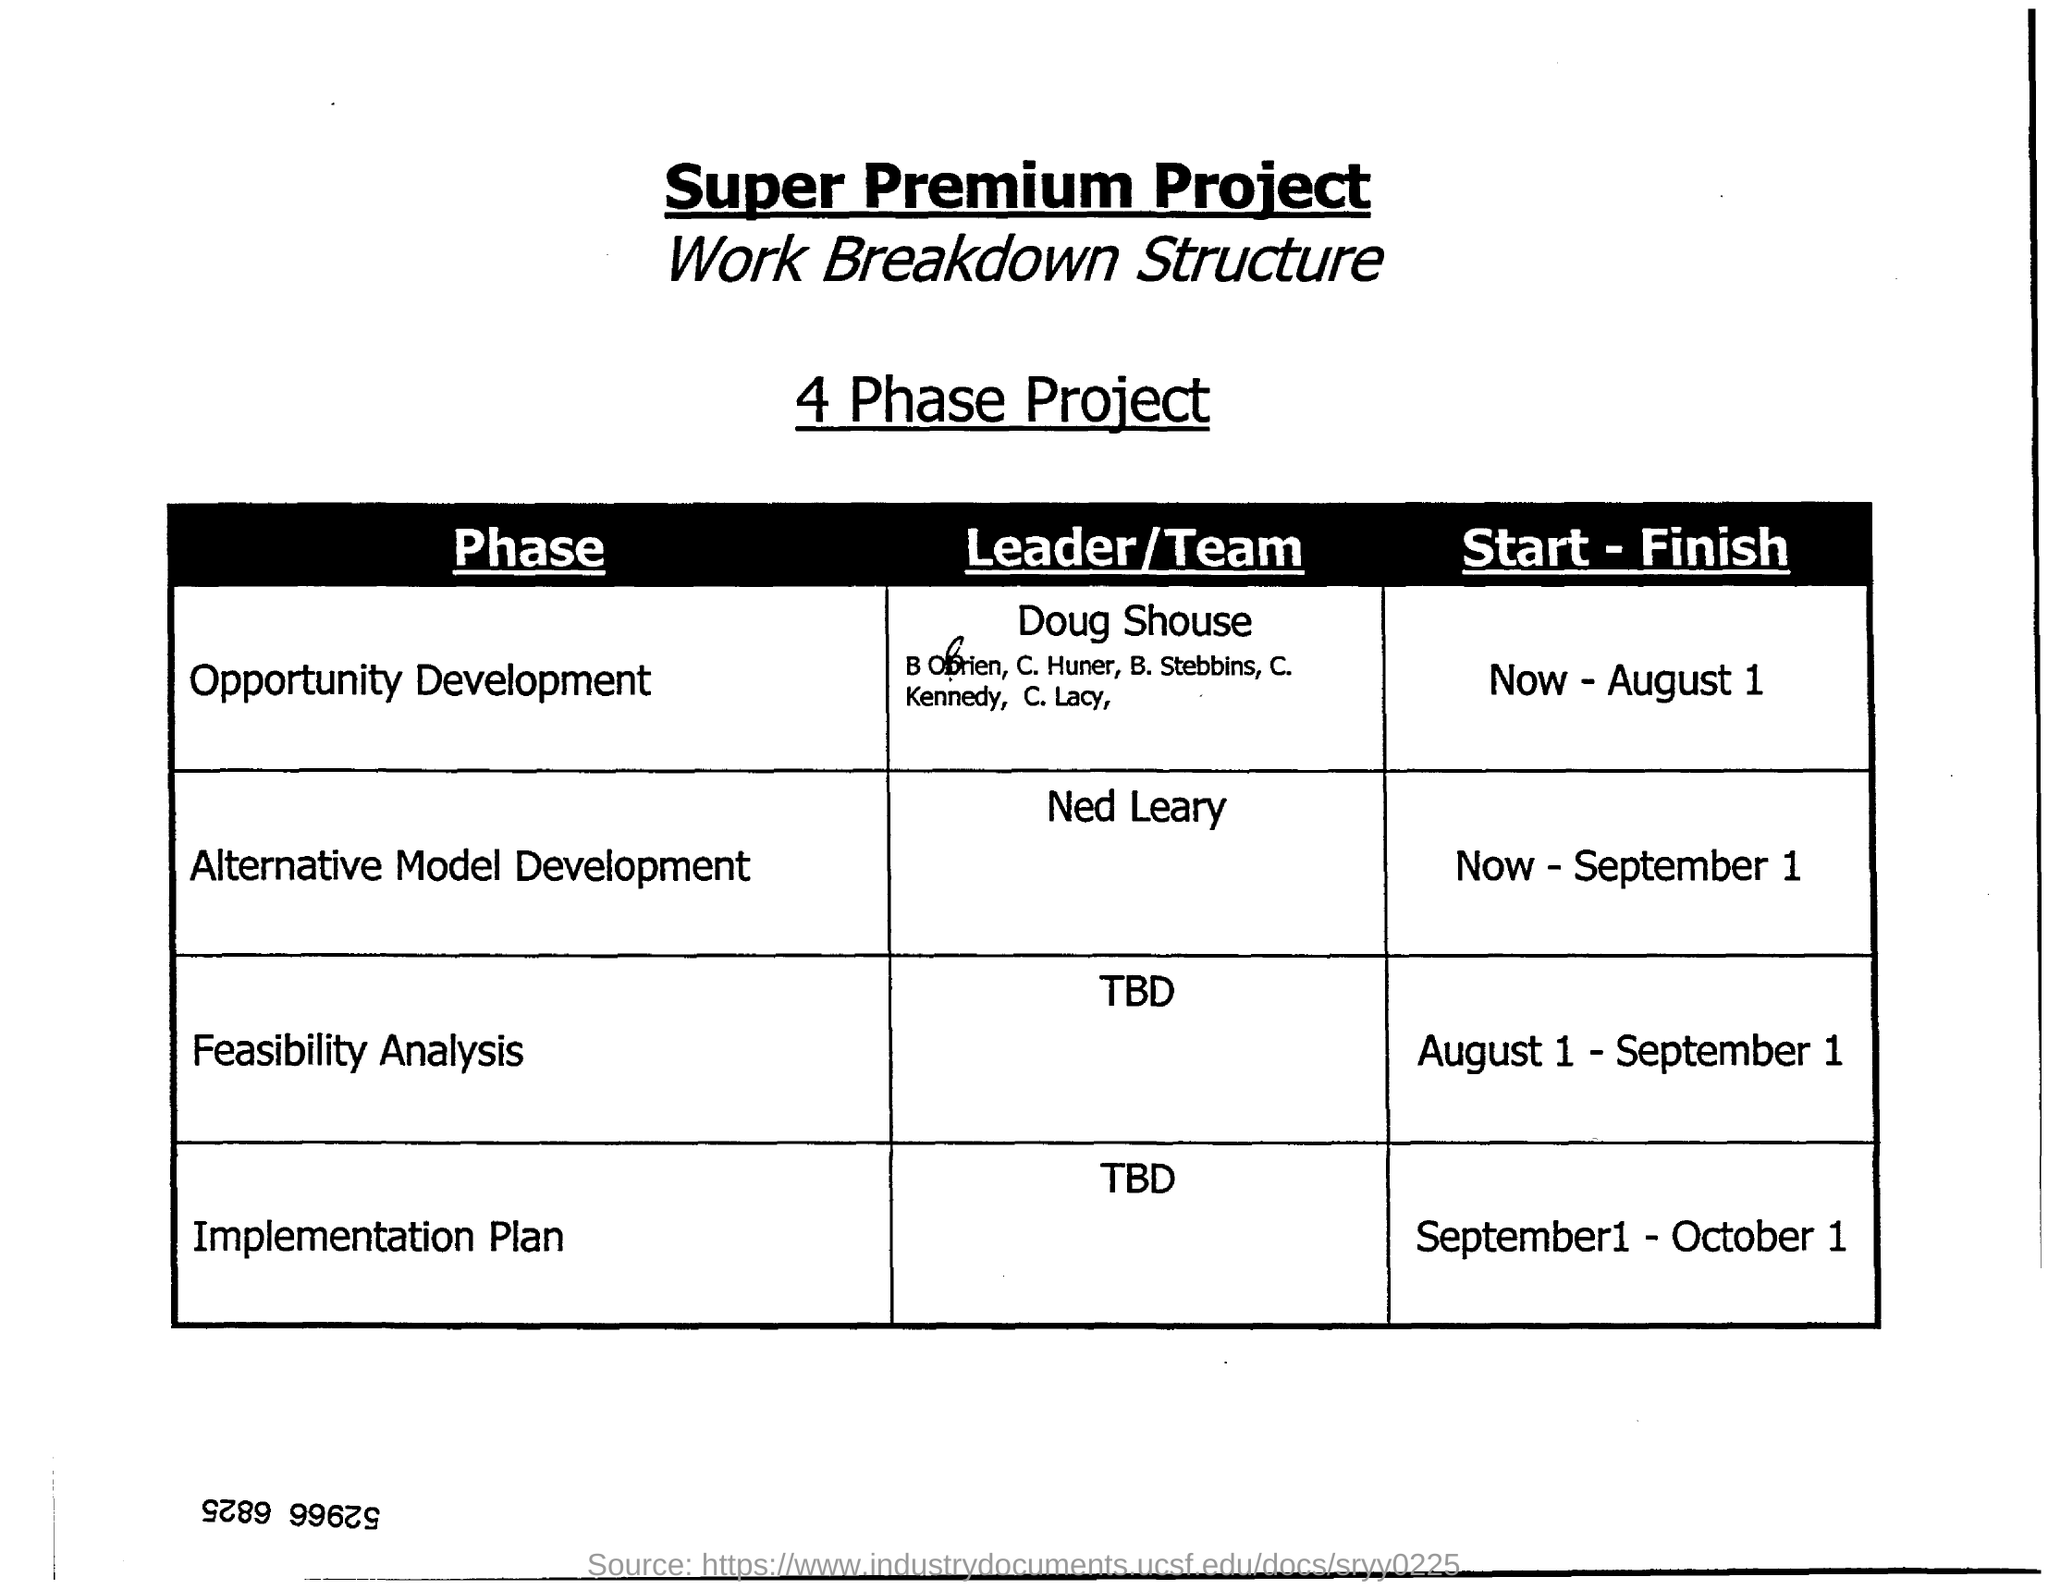Who is the Leader/Team for Alternative Model Development?
Keep it short and to the point. Ned Leary. What is the Start - Finish for Feasibility Analysis?
Keep it short and to the point. August 1 - September 1. 